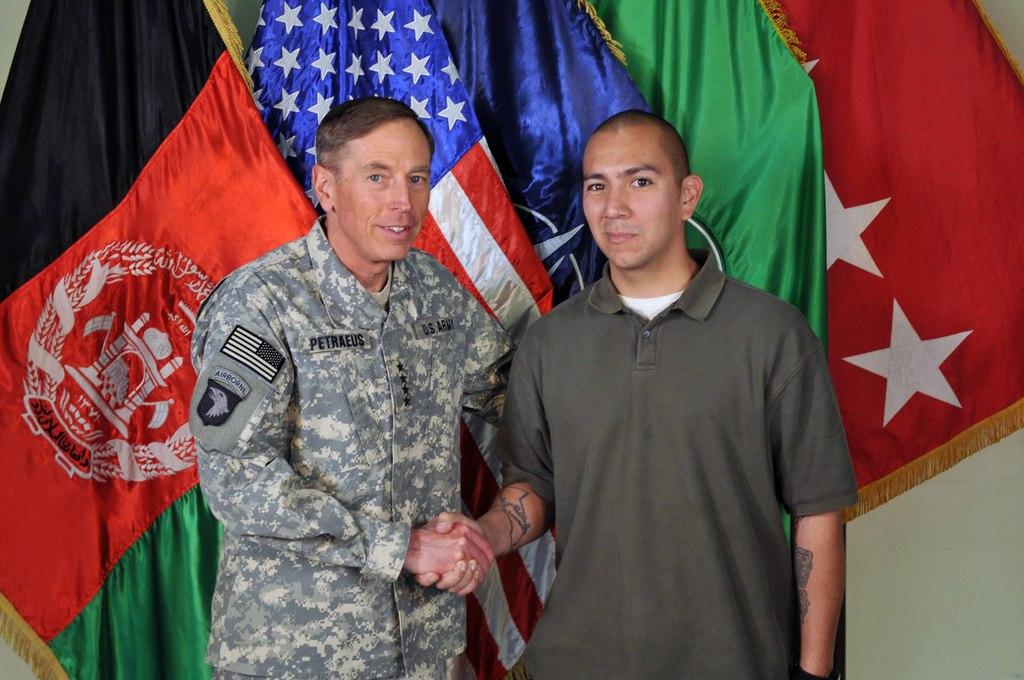Provide a one-sentence caption for the provided image. Former CIA Director Petraeus shakes hands with a fan. 